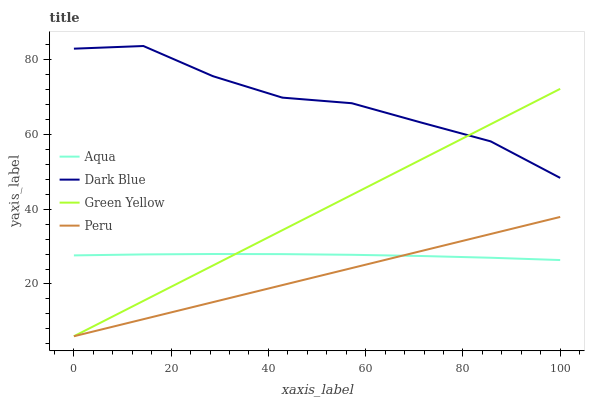Does Peru have the minimum area under the curve?
Answer yes or no. Yes. Does Dark Blue have the maximum area under the curve?
Answer yes or no. Yes. Does Green Yellow have the minimum area under the curve?
Answer yes or no. No. Does Green Yellow have the maximum area under the curve?
Answer yes or no. No. Is Peru the smoothest?
Answer yes or no. Yes. Is Dark Blue the roughest?
Answer yes or no. Yes. Is Green Yellow the smoothest?
Answer yes or no. No. Is Green Yellow the roughest?
Answer yes or no. No. Does Green Yellow have the lowest value?
Answer yes or no. Yes. Does Aqua have the lowest value?
Answer yes or no. No. Does Dark Blue have the highest value?
Answer yes or no. Yes. Does Green Yellow have the highest value?
Answer yes or no. No. Is Aqua less than Dark Blue?
Answer yes or no. Yes. Is Dark Blue greater than Aqua?
Answer yes or no. Yes. Does Aqua intersect Peru?
Answer yes or no. Yes. Is Aqua less than Peru?
Answer yes or no. No. Is Aqua greater than Peru?
Answer yes or no. No. Does Aqua intersect Dark Blue?
Answer yes or no. No. 